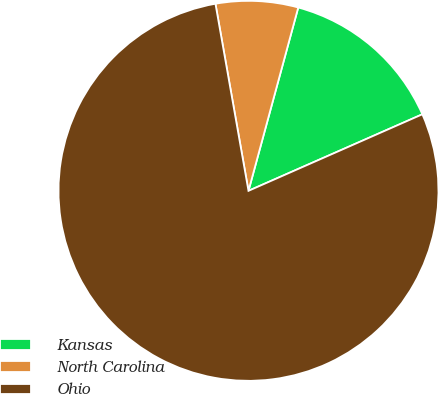Convert chart. <chart><loc_0><loc_0><loc_500><loc_500><pie_chart><fcel>Kansas<fcel>North Carolina<fcel>Ohio<nl><fcel>14.18%<fcel>7.0%<fcel>78.81%<nl></chart> 